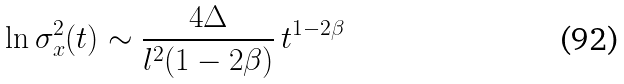Convert formula to latex. <formula><loc_0><loc_0><loc_500><loc_500>\ln \sigma _ { x } ^ { 2 } ( t ) \sim \frac { 4 \Delta } { l ^ { 2 } ( 1 - 2 \beta ) } \, t ^ { 1 - 2 \beta }</formula> 